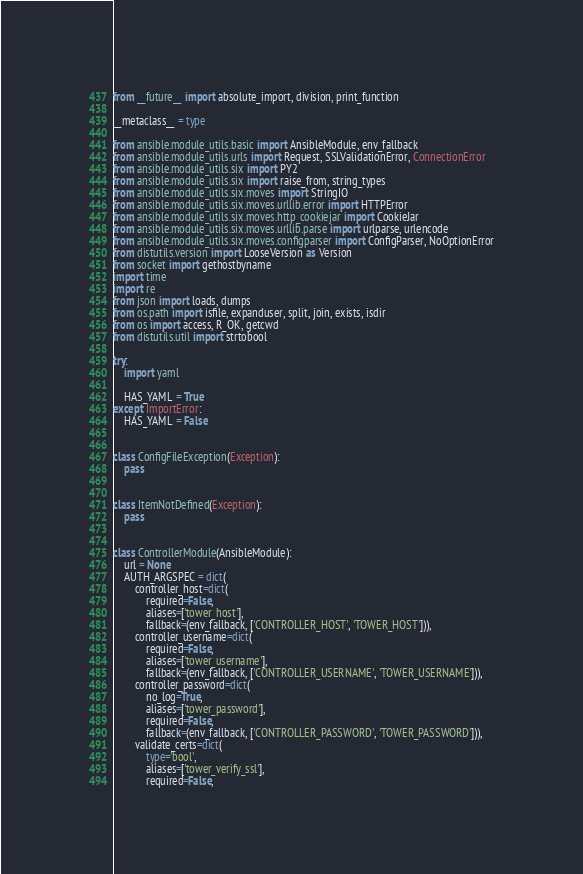<code> <loc_0><loc_0><loc_500><loc_500><_Python_>from __future__ import absolute_import, division, print_function

__metaclass__ = type

from ansible.module_utils.basic import AnsibleModule, env_fallback
from ansible.module_utils.urls import Request, SSLValidationError, ConnectionError
from ansible.module_utils.six import PY2
from ansible.module_utils.six import raise_from, string_types
from ansible.module_utils.six.moves import StringIO
from ansible.module_utils.six.moves.urllib.error import HTTPError
from ansible.module_utils.six.moves.http_cookiejar import CookieJar
from ansible.module_utils.six.moves.urllib.parse import urlparse, urlencode
from ansible.module_utils.six.moves.configparser import ConfigParser, NoOptionError
from distutils.version import LooseVersion as Version
from socket import gethostbyname
import time
import re
from json import loads, dumps
from os.path import isfile, expanduser, split, join, exists, isdir
from os import access, R_OK, getcwd
from distutils.util import strtobool

try:
    import yaml

    HAS_YAML = True
except ImportError:
    HAS_YAML = False


class ConfigFileException(Exception):
    pass


class ItemNotDefined(Exception):
    pass


class ControllerModule(AnsibleModule):
    url = None
    AUTH_ARGSPEC = dict(
        controller_host=dict(
            required=False,
            aliases=['tower_host'],
            fallback=(env_fallback, ['CONTROLLER_HOST', 'TOWER_HOST'])),
        controller_username=dict(
            required=False,
            aliases=['tower_username'],
            fallback=(env_fallback, ['CONTROLLER_USERNAME', 'TOWER_USERNAME'])),
        controller_password=dict(
            no_log=True,
            aliases=['tower_password'],
            required=False,
            fallback=(env_fallback, ['CONTROLLER_PASSWORD', 'TOWER_PASSWORD'])),
        validate_certs=dict(
            type='bool',
            aliases=['tower_verify_ssl'],
            required=False,</code> 